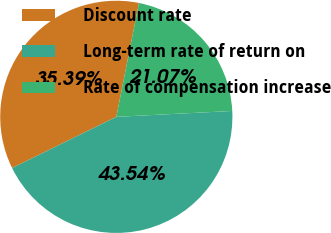Convert chart. <chart><loc_0><loc_0><loc_500><loc_500><pie_chart><fcel>Discount rate<fcel>Long-term rate of return on<fcel>Rate of compensation increase<nl><fcel>35.39%<fcel>43.54%<fcel>21.07%<nl></chart> 